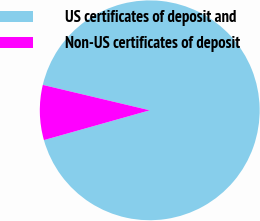Convert chart. <chart><loc_0><loc_0><loc_500><loc_500><pie_chart><fcel>US certificates of deposit and<fcel>Non-US certificates of deposit<nl><fcel>91.92%<fcel>8.08%<nl></chart> 